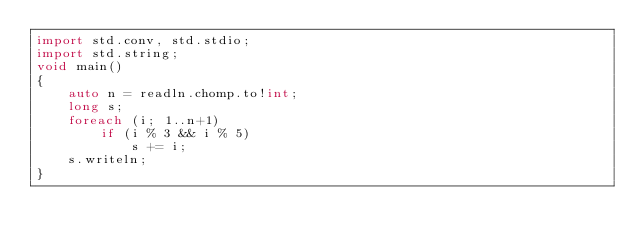Convert code to text. <code><loc_0><loc_0><loc_500><loc_500><_D_>import std.conv, std.stdio;
import std.string;
void main()
{
    auto n = readln.chomp.to!int;
    long s;
    foreach (i; 1..n+1)
        if (i % 3 && i % 5)
            s += i;
    s.writeln;
}
</code> 